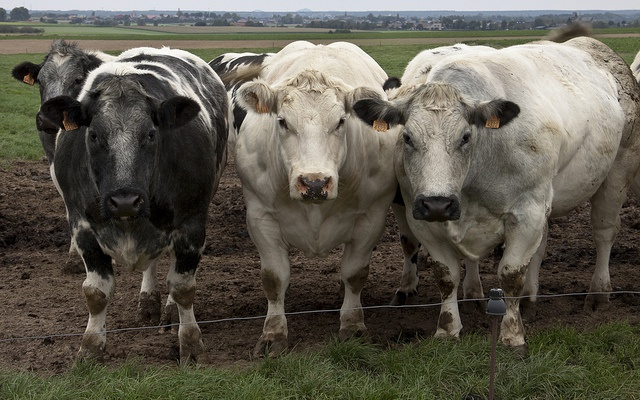Describe the objects in this image and their specific colors. I can see cow in lightgray, gray, black, and darkgray tones, cow in lightgray, black, and gray tones, cow in lightgray, gray, black, and darkgray tones, cow in lightgray, black, gray, and darkgray tones, and cow in lightgray, darkgray, and gray tones in this image. 